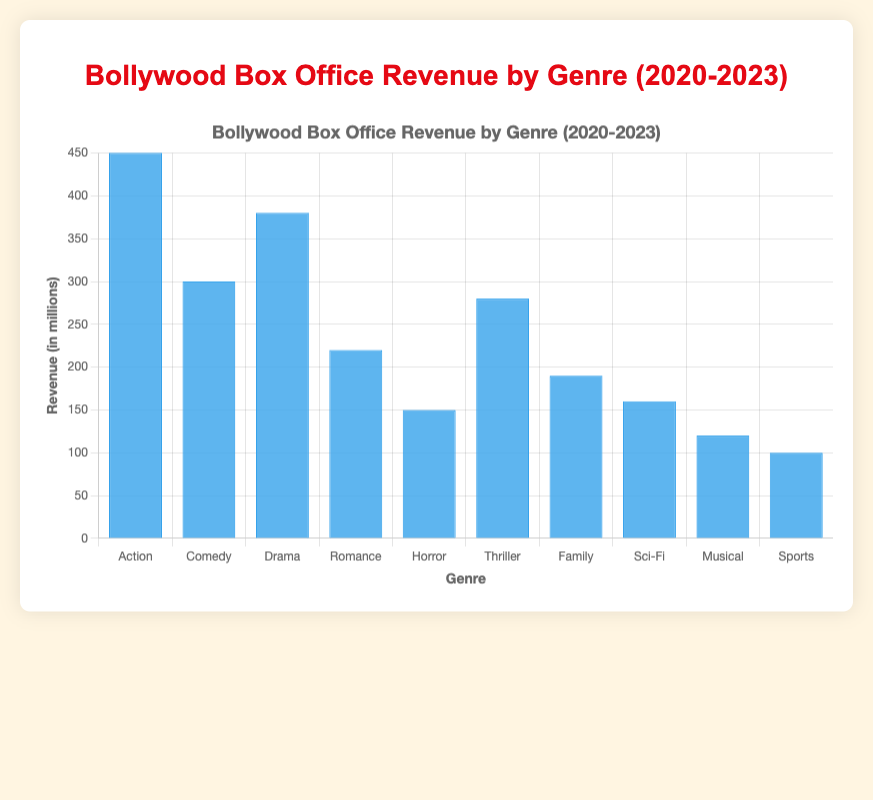Which genre has the highest box office revenue? The genre with the highest bar represents the action, indicating the highest revenue.
Answer: Action What is the difference in revenue between the Action and Comedy genres? The revenue for Action is 450 million, and for Comedy, it is 300 million. Subtracting the two gives us 450 - 300 = 150 million.
Answer: 150 million Which genre has the lowest box office revenue? The shortest bar corresponds to the Sports genre, which has the lowest revenue.
Answer: Sports How much revenue do the Drama and Thriller genres generate together? The revenues for Drama and Thriller are 380 million and 280 million respectively. Adding them gives us 380 + 280 = 660 million.
Answer: 660 million By how much does the revenue of the Horror genre exceed that of the Family genre? Horror has a revenue of 150 million, and Family has 190 million. The difference is 190 - 150 = 40 million.
Answer: 40 million What is the average revenue of the top three genres? Action, Drama, and Comedy are the top three genres with revenues of 450, 380, and 300 million. The average is (450 + 380 + 300)/3 = 1130/3 = 376.67 million.
Answer: 376.67 million What would be the median revenue if Horror and Musical genres' revenues were swapped? The current median revenue (5th and 6th) in sorted order is between Family (190) and Romance (220). Swapping Horror (150) and Musical (120) doesn't change these values. The median remains 190.
Answer: 190 million Which genre has the second highest revenue, and how close is it to the highest? Drama is the second highest with 380 million, close to Action's 450 million. The difference is 450 - 380 = 70 million.
Answer: Drama, 70 million Compare the total revenue of Sci-Fi, Musical, and Sports genres with that of the Comedy genre. Sci-Fi (160), Musical (120), and Sports (100) add up to 380 million, which exceeds Comedy's 300 million by 80 million (380 - 300).
Answer: 80 million What is the overall revenue of all genres combined and its average? Summing revenues of all genres: 450 + 300 + 380 + 220 + 150 + 280 + 190 + 160 + 120 + 100 = 2350 million. Dividing by 10 genres gives the average: 2350/10 = 235 million.
Answer: 2350 million, 235 million 